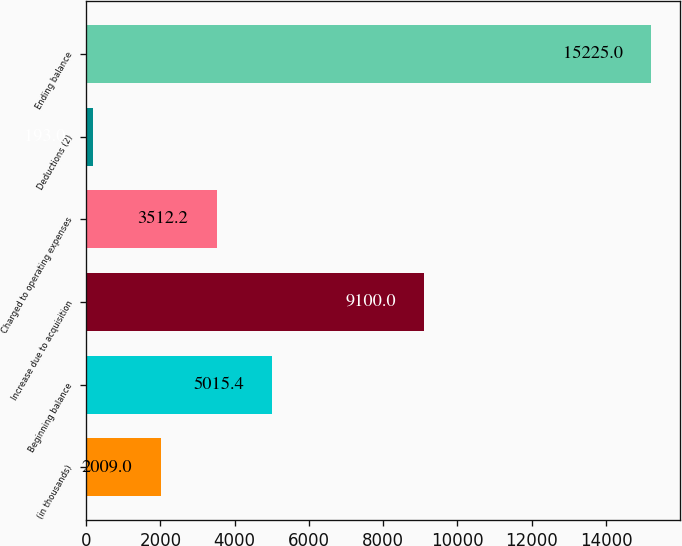Convert chart to OTSL. <chart><loc_0><loc_0><loc_500><loc_500><bar_chart><fcel>(in thousands)<fcel>Beginning balance<fcel>Increase due to acquisition<fcel>Charged to operating expenses<fcel>Deductions (2)<fcel>Ending balance<nl><fcel>2009<fcel>5015.4<fcel>9100<fcel>3512.2<fcel>193<fcel>15225<nl></chart> 